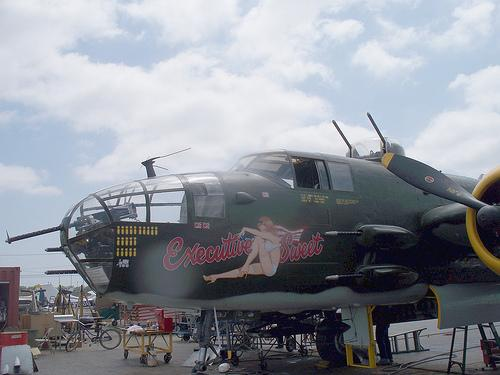Tell me about the sky in the image. The sky is a mix of blue and clouds, filled with white clouds. Describe the propeller of the plane in the image. The propeller on the plane has a grey and yellow color and features large propeller blades. What type of event is the bomber likely displayed at? The bomber is likely displayed at an air show. What type of vehicle is the main focus in this image? A vintage World War II B17 fighter airplane is the main focus of this image. For the referential expression grounding task, identify the item close to the aircraft on the ground. A silver metal ladder is lying on the ground close to the aircraft. What color is the cart with wheels in the image? The cart with wheels is yellow. Where is the person in relation to the aircraft? There is a person standing under the aircraft, possibly working on it. What can be seen painted on the side of the aircraft? A girl, an American flag, red words saying "executive sweet," and symbols for enemy kills are painted on the side of the aircraft. What can you say about the weaponry on the plane? There are machine guns on the side of the plane and a gun barrel of a machine gun can also be seen. Can you describe the bicycle's location in relation to the plane? The bicycle is parked beside the plane at the air field. 